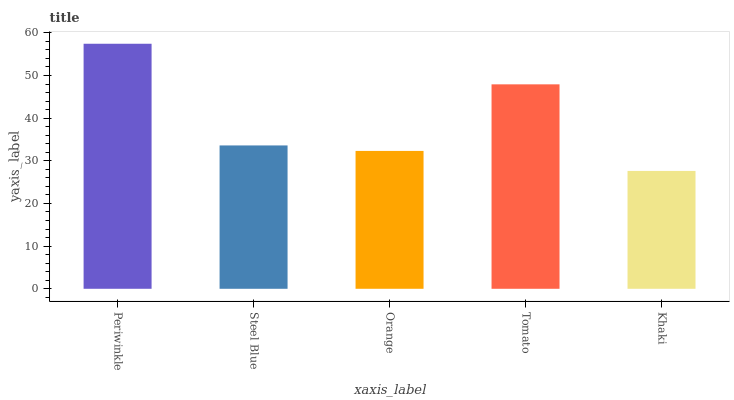Is Khaki the minimum?
Answer yes or no. Yes. Is Periwinkle the maximum?
Answer yes or no. Yes. Is Steel Blue the minimum?
Answer yes or no. No. Is Steel Blue the maximum?
Answer yes or no. No. Is Periwinkle greater than Steel Blue?
Answer yes or no. Yes. Is Steel Blue less than Periwinkle?
Answer yes or no. Yes. Is Steel Blue greater than Periwinkle?
Answer yes or no. No. Is Periwinkle less than Steel Blue?
Answer yes or no. No. Is Steel Blue the high median?
Answer yes or no. Yes. Is Steel Blue the low median?
Answer yes or no. Yes. Is Tomato the high median?
Answer yes or no. No. Is Khaki the low median?
Answer yes or no. No. 